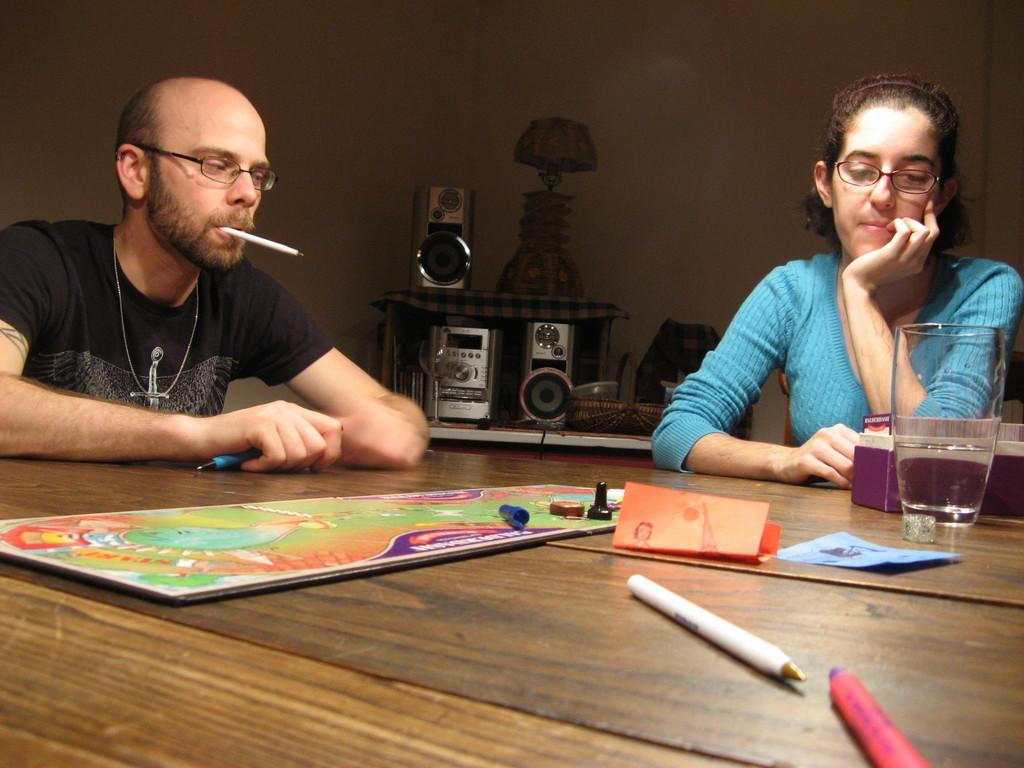How would you summarize this image in a sentence or two? This is a picture of a room. To the right of the image there is a woman seated, to the left of the image there is a man seated holding a pen in his mouth and in his hand. In the foreground there is a table, on the table there is a book, paper, glass, box and pens. In the background there is a table, on the table there are speakers and a lamp. 